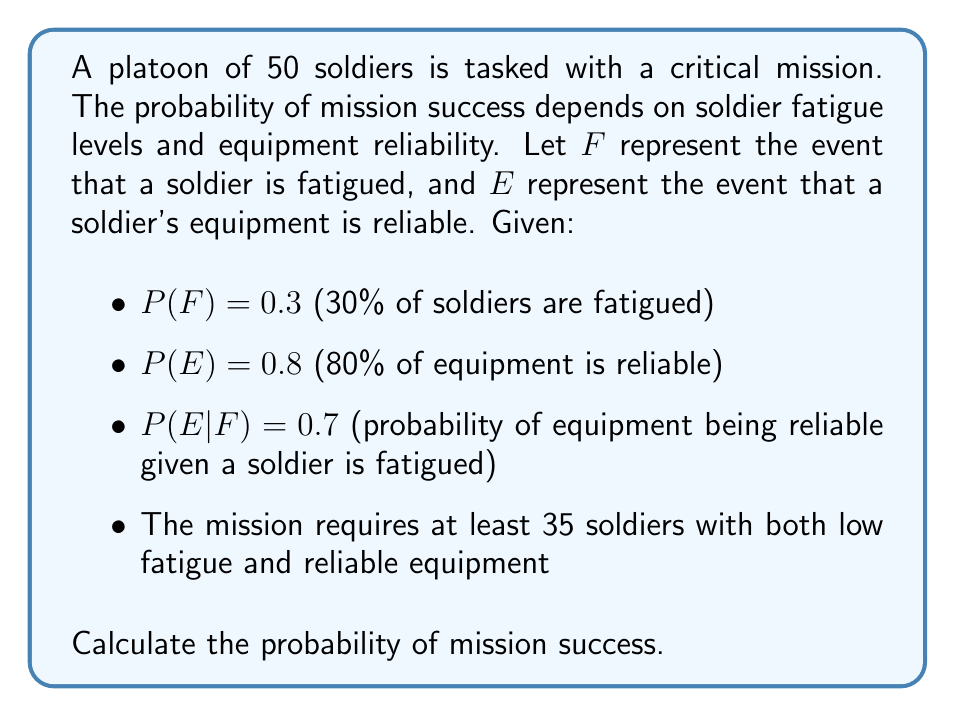Show me your answer to this math problem. 1) First, we need to find $P(F^c \cap E)$, the probability that a soldier is not fatigued and has reliable equipment.

2) Using the law of total probability:
   $P(E) = P(E|F)P(F) + P(E|F^c)P(F^c)$

3) We know $P(E) = 0.8$, $P(E|F) = 0.7$, and $P(F) = 0.3$. Let's solve for $P(E|F^c)$:
   $0.8 = 0.7 \cdot 0.3 + P(E|F^c) \cdot 0.7$
   $0.8 = 0.21 + 0.7P(E|F^c)$
   $0.59 = 0.7P(E|F^c)$
   $P(E|F^c) = 0.8429$

4) Now we can calculate $P(F^c \cap E)$:
   $P(F^c \cap E) = P(E|F^c)P(F^c) = 0.8429 \cdot 0.7 = 0.5900$

5) The probability of a soldier being suitable for the mission is 0.5900.

6) We can model this as a binomial distribution with $n = 50$ and $p = 0.5900$.

7) We need at least 35 suitable soldiers, so we're looking for $P(X \geq 35)$ where $X \sim B(50, 0.5900)$.

8) Using the cumulative binomial probability:
   $P(X \geq 35) = 1 - P(X < 35) = 1 - P(X \leq 34)$

9) This can be calculated using the binomial cumulative distribution function:
   $P(X \geq 35) = 1 - \sum_{k=0}^{34} \binom{50}{k} (0.5900)^k (0.4100)^{50-k}$

10) Using a calculator or computer, we find:
    $P(X \geq 35) \approx 0.9761$
Answer: 0.9761 